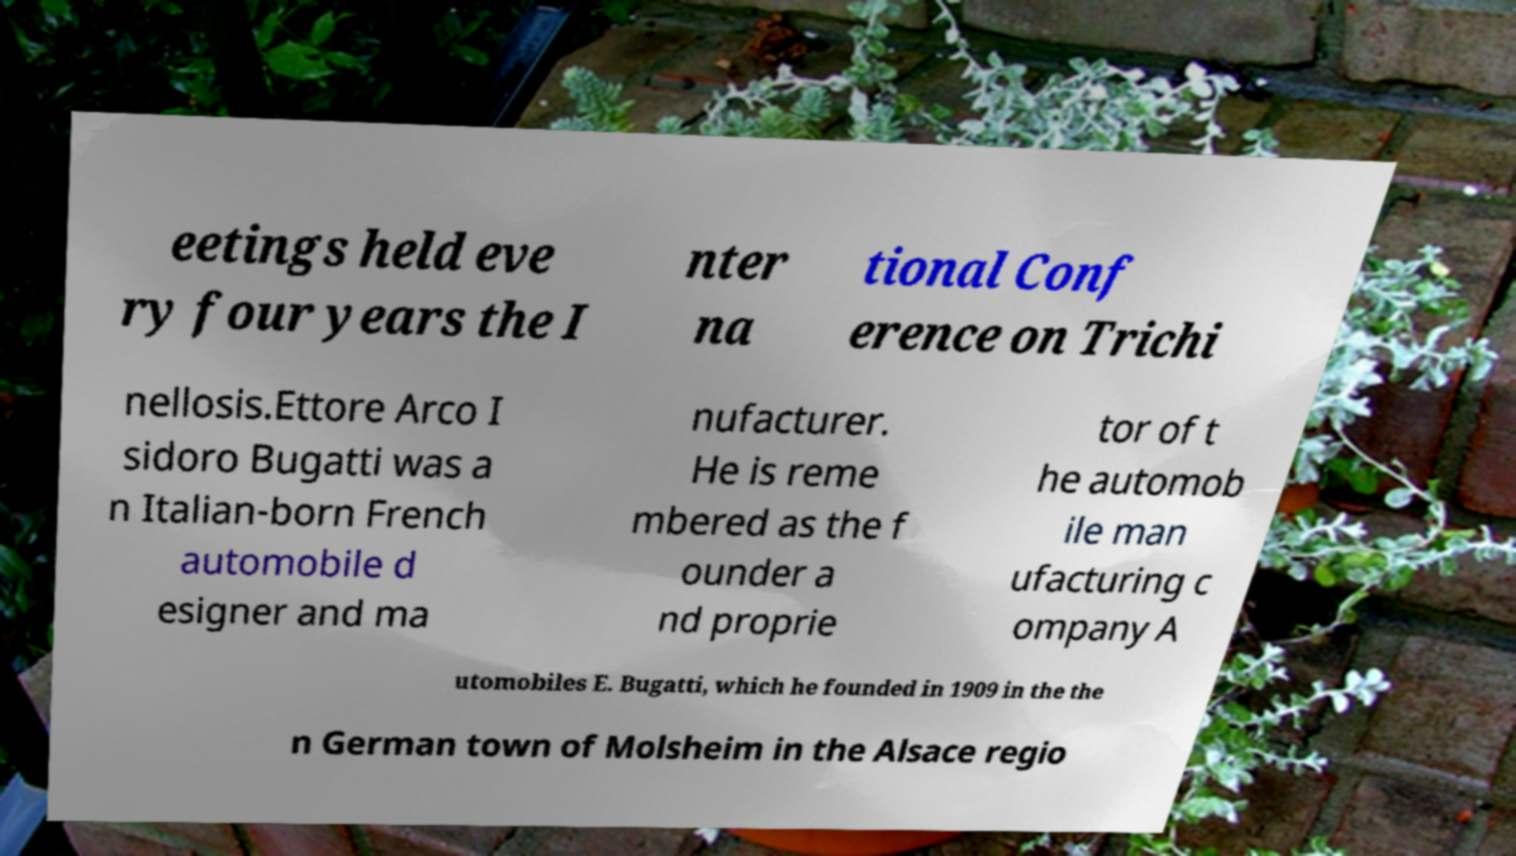Please identify and transcribe the text found in this image. eetings held eve ry four years the I nter na tional Conf erence on Trichi nellosis.Ettore Arco I sidoro Bugatti was a n Italian-born French automobile d esigner and ma nufacturer. He is reme mbered as the f ounder a nd proprie tor of t he automob ile man ufacturing c ompany A utomobiles E. Bugatti, which he founded in 1909 in the the n German town of Molsheim in the Alsace regio 